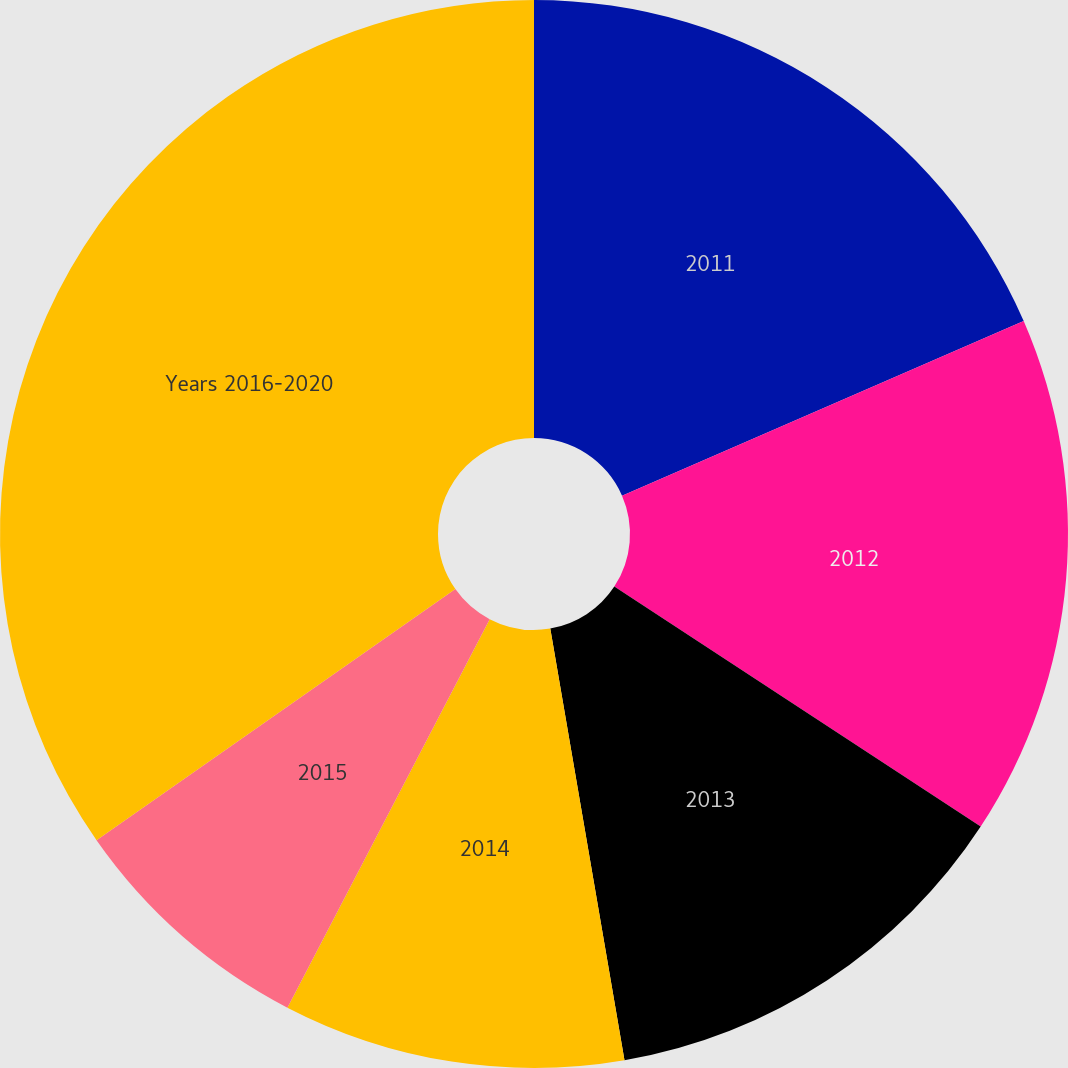Convert chart. <chart><loc_0><loc_0><loc_500><loc_500><pie_chart><fcel>2011<fcel>2012<fcel>2013<fcel>2014<fcel>2015<fcel>Years 2016-2020<nl><fcel>18.47%<fcel>15.76%<fcel>13.06%<fcel>10.35%<fcel>7.64%<fcel>34.72%<nl></chart> 